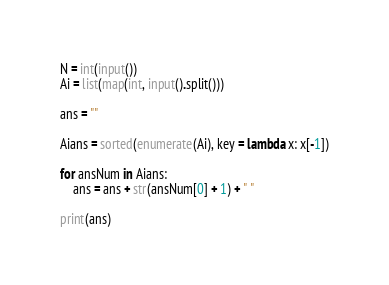Convert code to text. <code><loc_0><loc_0><loc_500><loc_500><_Python_>N = int(input())
Ai = list(map(int, input().split()))

ans = ""

Aians = sorted(enumerate(Ai), key = lambda x: x[-1])

for ansNum in Aians:
    ans = ans + str(ansNum[0] + 1) + " "

print(ans)</code> 